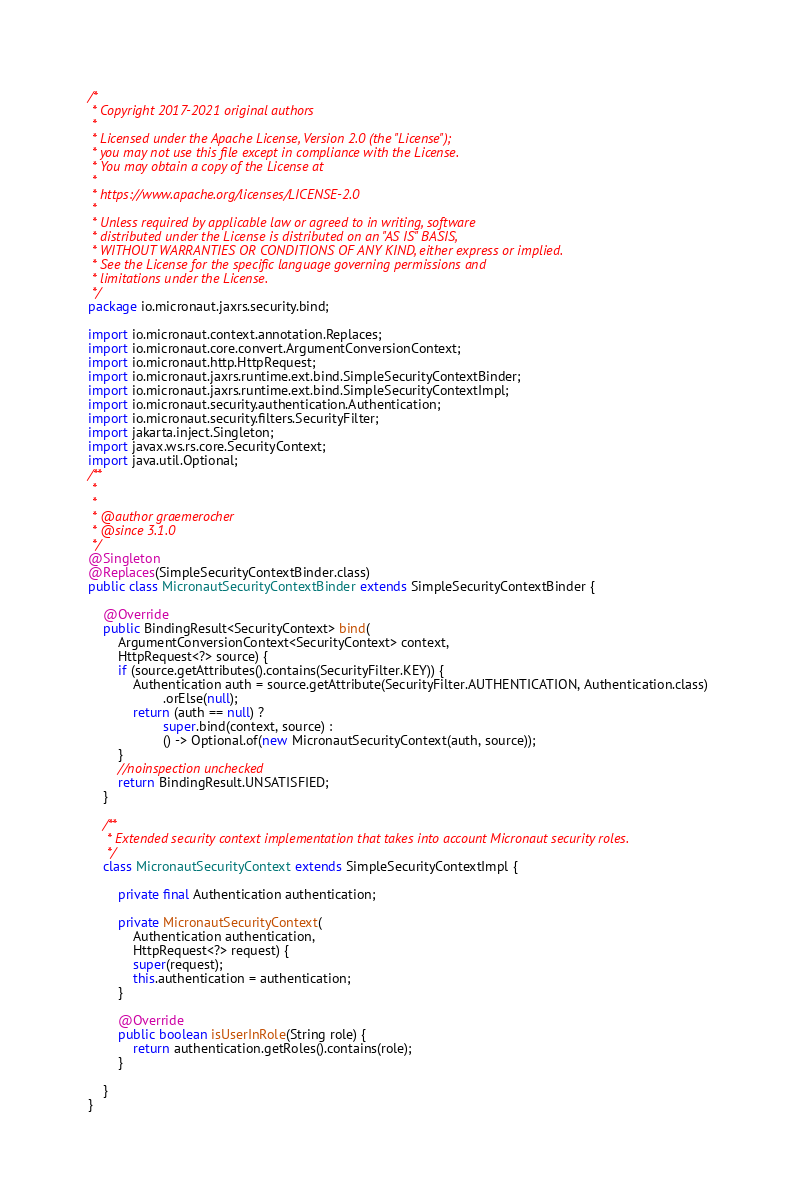<code> <loc_0><loc_0><loc_500><loc_500><_Java_>/*
 * Copyright 2017-2021 original authors
 *
 * Licensed under the Apache License, Version 2.0 (the "License");
 * you may not use this file except in compliance with the License.
 * You may obtain a copy of the License at
 *
 * https://www.apache.org/licenses/LICENSE-2.0
 *
 * Unless required by applicable law or agreed to in writing, software
 * distributed under the License is distributed on an "AS IS" BASIS,
 * WITHOUT WARRANTIES OR CONDITIONS OF ANY KIND, either express or implied.
 * See the License for the specific language governing permissions and
 * limitations under the License.
 */
package io.micronaut.jaxrs.security.bind;

import io.micronaut.context.annotation.Replaces;
import io.micronaut.core.convert.ArgumentConversionContext;
import io.micronaut.http.HttpRequest;
import io.micronaut.jaxrs.runtime.ext.bind.SimpleSecurityContextBinder;
import io.micronaut.jaxrs.runtime.ext.bind.SimpleSecurityContextImpl;
import io.micronaut.security.authentication.Authentication;
import io.micronaut.security.filters.SecurityFilter;
import jakarta.inject.Singleton;
import javax.ws.rs.core.SecurityContext;
import java.util.Optional;
/**
 *
 *
 * @author graemerocher
 * @since 3.1.0
 */
@Singleton 
@Replaces(SimpleSecurityContextBinder.class)
public class MicronautSecurityContextBinder extends SimpleSecurityContextBinder {

    @Override
    public BindingResult<SecurityContext> bind(
        ArgumentConversionContext<SecurityContext> context, 
        HttpRequest<?> source) {
        if (source.getAttributes().contains(SecurityFilter.KEY)) {
            Authentication auth = source.getAttribute(SecurityFilter.AUTHENTICATION, Authentication.class)
                    .orElse(null);
            return (auth == null) ?
                    super.bind(context, source) :
                    () -> Optional.of(new MicronautSecurityContext(auth, source));
        }
        //noinspection unchecked
        return BindingResult.UNSATISFIED;
    }

    /**
     * Extended security context implementation that takes into account Micronaut security roles.
     */
    class MicronautSecurityContext extends SimpleSecurityContextImpl {

        private final Authentication authentication;

        private MicronautSecurityContext(
            Authentication authentication, 
            HttpRequest<?> request) {
            super(request);
            this.authentication = authentication;
        }

        @Override
        public boolean isUserInRole(String role) {
            return authentication.getRoles().contains(role);
        }
                
    }
}
</code> 